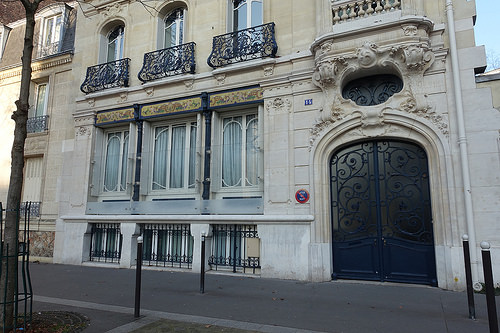<image>
Can you confirm if the tree is to the left of the balcony? No. The tree is not to the left of the balcony. From this viewpoint, they have a different horizontal relationship. 